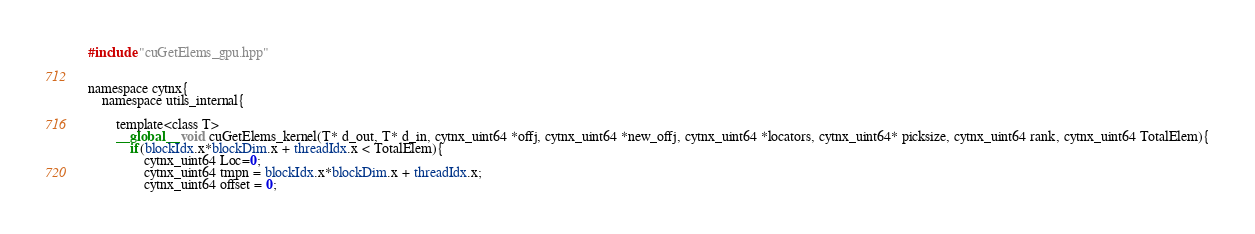Convert code to text. <code><loc_0><loc_0><loc_500><loc_500><_Cuda_>#include "cuGetElems_gpu.hpp"


namespace cytnx{
    namespace utils_internal{

        template<class T>
        __global__ void cuGetElems_kernel(T* d_out, T* d_in, cytnx_uint64 *offj, cytnx_uint64 *new_offj, cytnx_uint64 *locators, cytnx_uint64* picksize, cytnx_uint64 rank, cytnx_uint64 TotalElem){
            if(blockIdx.x*blockDim.x + threadIdx.x < TotalElem){
                cytnx_uint64 Loc=0;
                cytnx_uint64 tmpn = blockIdx.x*blockDim.x + threadIdx.x;
                cytnx_uint64 offset = 0;</code> 